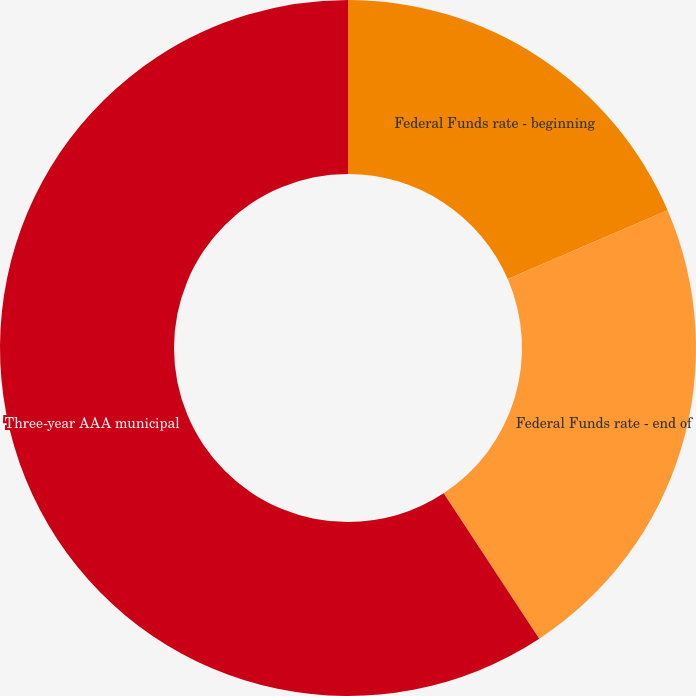<chart> <loc_0><loc_0><loc_500><loc_500><pie_chart><fcel>Federal Funds rate - beginning<fcel>Federal Funds rate - end of<fcel>Three-year AAA municipal<nl><fcel>18.52%<fcel>22.22%<fcel>59.26%<nl></chart> 